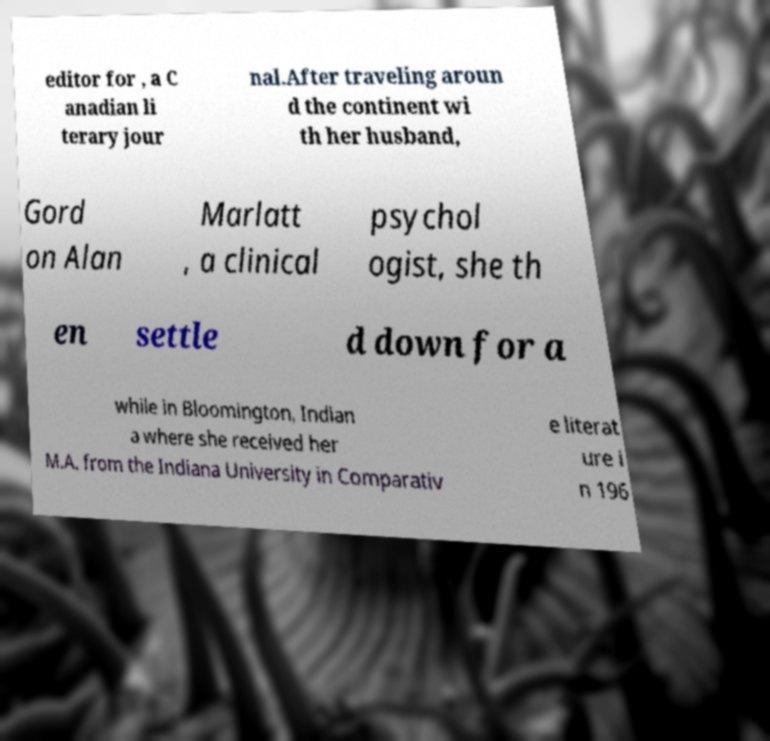There's text embedded in this image that I need extracted. Can you transcribe it verbatim? editor for , a C anadian li terary jour nal.After traveling aroun d the continent wi th her husband, Gord on Alan Marlatt , a clinical psychol ogist, she th en settle d down for a while in Bloomington, Indian a where she received her M.A. from the Indiana University in Comparativ e literat ure i n 196 